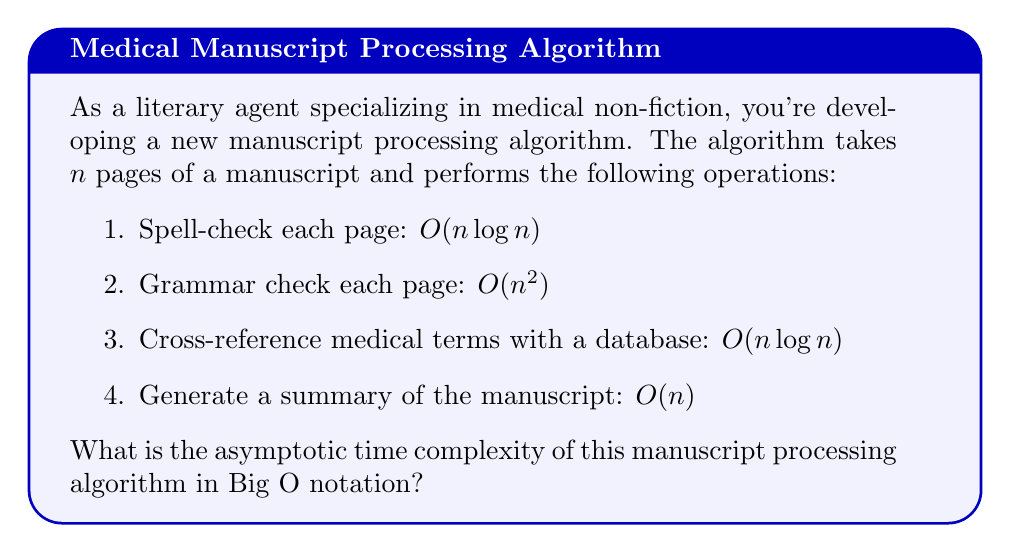Help me with this question. To determine the asymptotic time complexity of the entire algorithm, we need to analyze each step and combine them:

1. Spell-check: $O(n \log n)$
2. Grammar check: $O(n^2)$
3. Cross-reference: $O(n \log n)$
4. Generate summary: $O(n)$

When we have multiple steps in an algorithm, we add their complexities. However, in Big O notation, we only keep the term with the highest growth rate, as it dominates the overall complexity for large inputs.

Comparing the growth rates:
- $O(n)$ grows slower than $O(n \log n)$
- $O(n \log n)$ grows slower than $O(n^2)$

Therefore, the term with the highest growth rate is $O(n^2)$, which comes from the grammar check step.

Even though we perform other operations, their growth rates are all lower than $O(n^2)$, so they don't affect the overall asymptotic complexity.

Thus, the asymptotic time complexity of the entire manuscript processing algorithm is $O(n^2)$.
Answer: $O(n^2)$ 